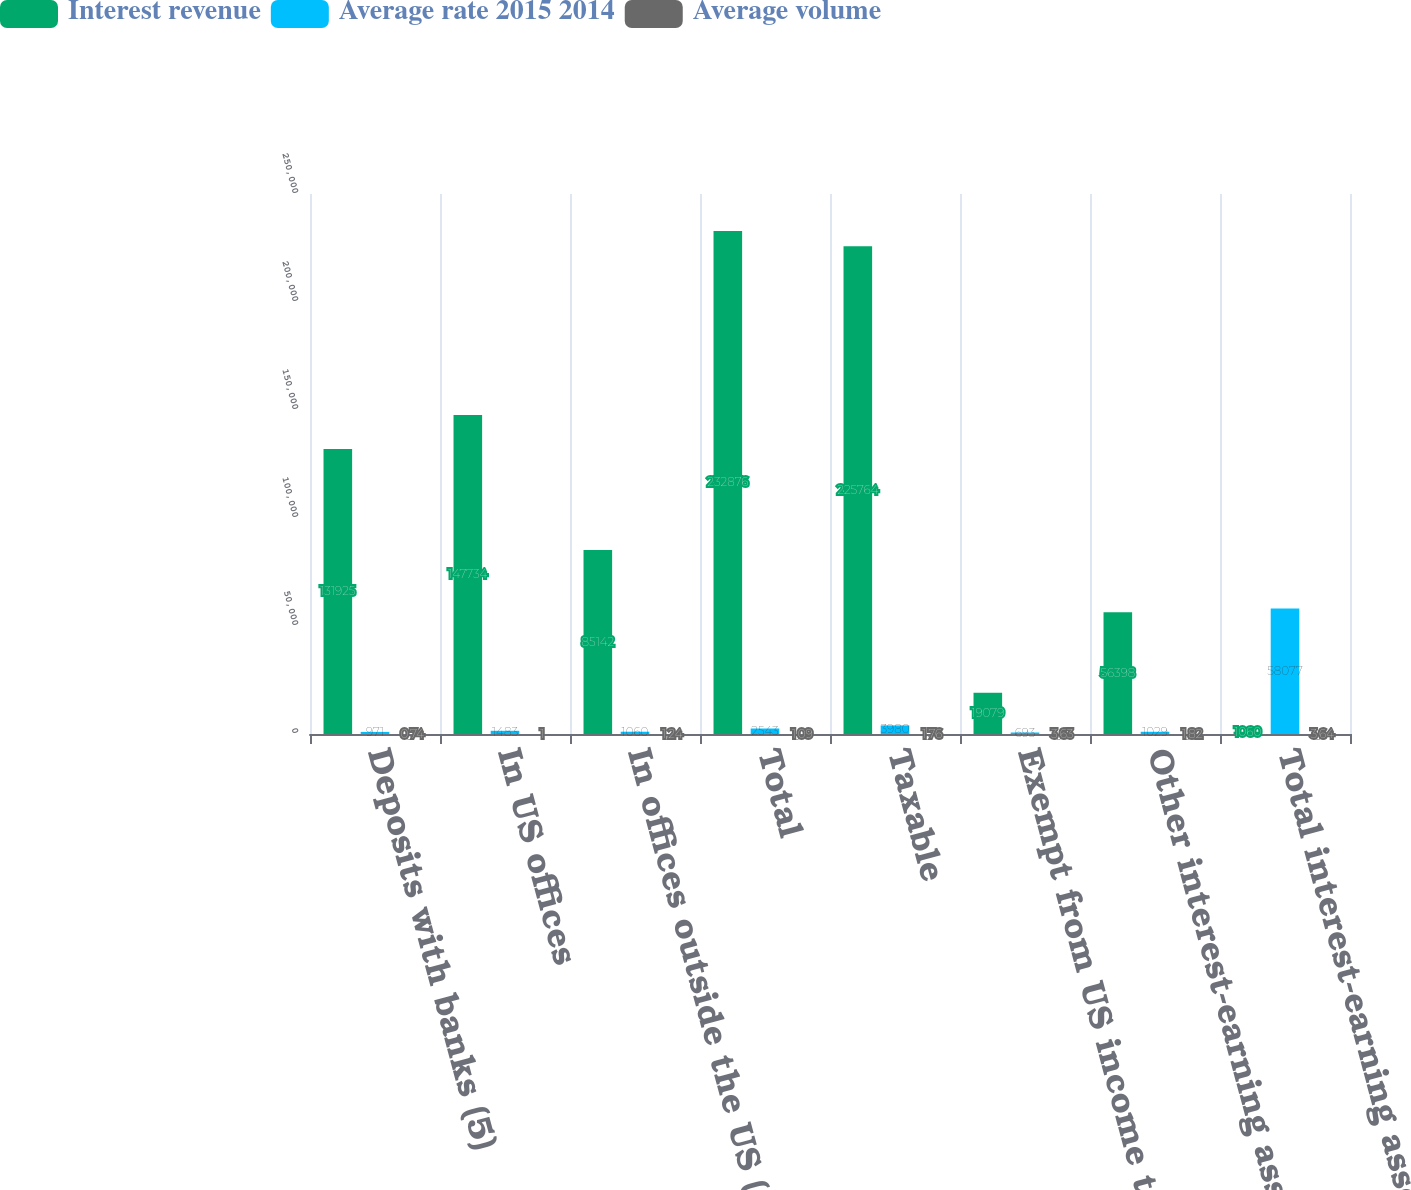<chart> <loc_0><loc_0><loc_500><loc_500><stacked_bar_chart><ecel><fcel>Deposits with banks (5)<fcel>In US offices<fcel>In offices outside the US (5)<fcel>Total<fcel>Taxable<fcel>Exempt from US income tax<fcel>Other interest-earning assets<fcel>Total interest-earning assets<nl><fcel>Interest revenue<fcel>131925<fcel>147734<fcel>85142<fcel>232876<fcel>225764<fcel>19079<fcel>56398<fcel>1060<nl><fcel>Average rate 2015 2014<fcel>971<fcel>1483<fcel>1060<fcel>2543<fcel>3980<fcel>693<fcel>1029<fcel>58077<nl><fcel>Average volume<fcel>0.74<fcel>1<fcel>1.24<fcel>1.09<fcel>1.76<fcel>3.63<fcel>1.82<fcel>3.64<nl></chart> 